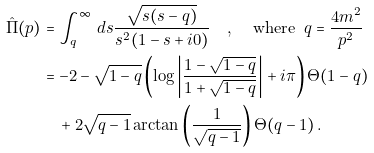Convert formula to latex. <formula><loc_0><loc_0><loc_500><loc_500>\hat { \Pi } ( p ) & = \int _ { q } ^ { \infty } \, d s \frac { \sqrt { s ( s - q ) } } { s ^ { 2 } ( 1 - s + i 0 ) } \quad , \, \quad \text {where } \, q = \frac { 4 m ^ { 2 } } { p ^ { 2 } } \\ & = - 2 - \sqrt { 1 - q } \left ( \log \left | \frac { 1 - \sqrt { 1 - q } } { 1 + \sqrt { 1 - q } } \right | + i \pi \right ) \Theta ( 1 - q ) \\ & \quad + 2 \sqrt { q - 1 } \arctan \left ( \frac { 1 } { \sqrt { q - 1 } } \right ) \Theta ( q - 1 ) \, .</formula> 